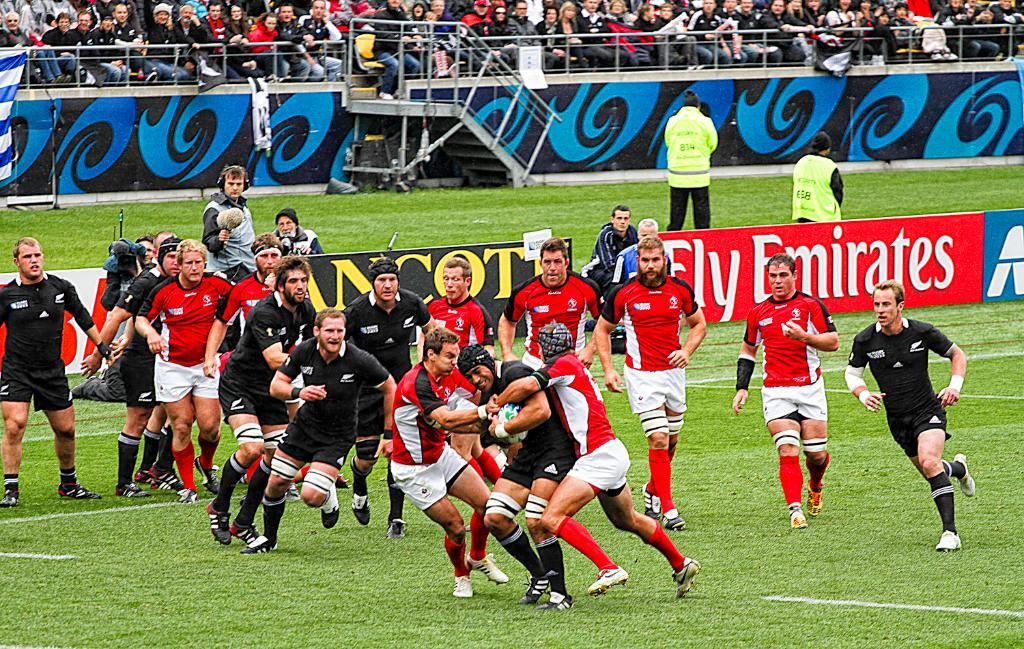<image>
Write a terse but informative summary of the picture. Two teams battle for the rugby ball in front of a Fly Emirates sign. 